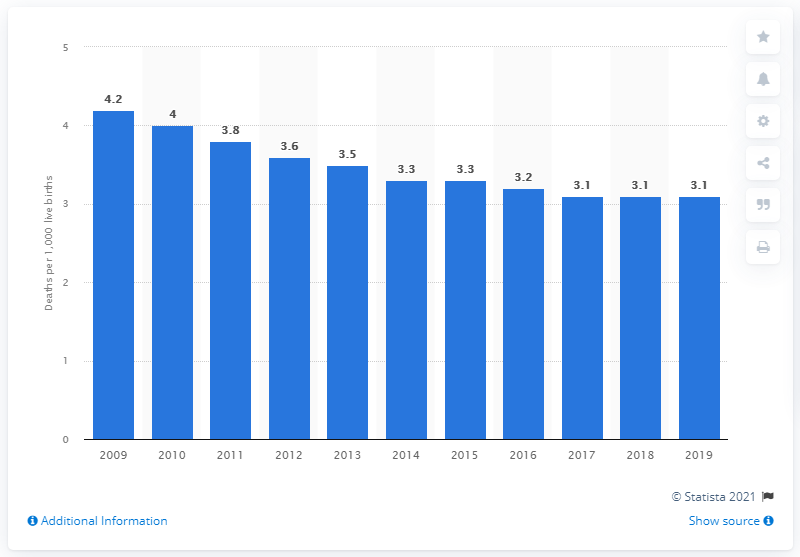Give some essential details in this illustration. In 2019, the infant mortality rate in Australia was 3.1 deaths per 1,000 live births. 